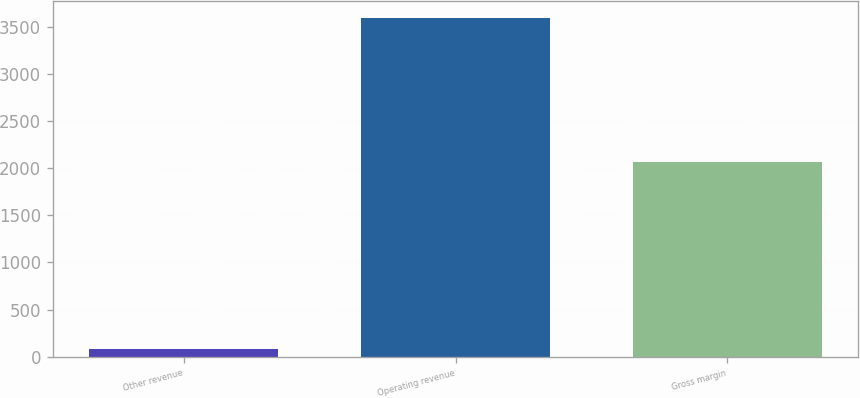Convert chart to OTSL. <chart><loc_0><loc_0><loc_500><loc_500><bar_chart><fcel>Other revenue<fcel>Operating revenue<fcel>Gross margin<nl><fcel>78<fcel>3592<fcel>2062<nl></chart> 